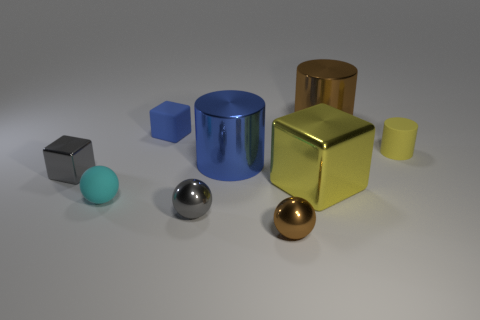Subtract all cylinders. How many objects are left? 6 Subtract 0 yellow spheres. How many objects are left? 9 Subtract all large yellow blocks. Subtract all tiny yellow matte cylinders. How many objects are left? 7 Add 9 big blue things. How many big blue things are left? 10 Add 5 matte objects. How many matte objects exist? 8 